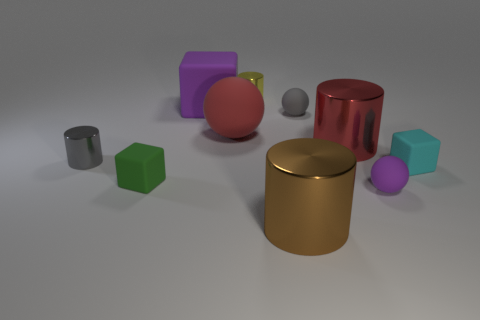Subtract all green blocks. Subtract all red cylinders. How many blocks are left? 2 Subtract all blocks. How many objects are left? 7 Add 1 tiny cyan spheres. How many tiny cyan spheres exist? 1 Subtract 0 cyan cylinders. How many objects are left? 10 Subtract all cylinders. Subtract all red matte spheres. How many objects are left? 5 Add 1 red rubber spheres. How many red rubber spheres are left? 2 